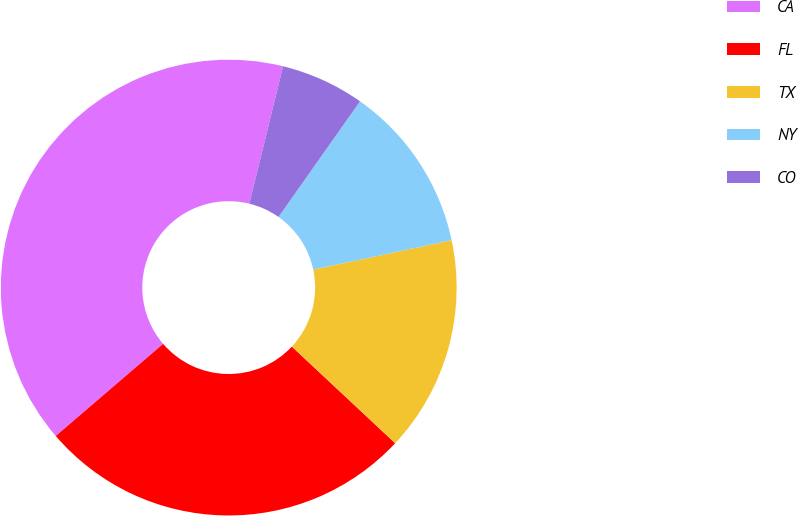Convert chart to OTSL. <chart><loc_0><loc_0><loc_500><loc_500><pie_chart><fcel>CA<fcel>FL<fcel>TX<fcel>NY<fcel>CO<nl><fcel>40.12%<fcel>26.75%<fcel>15.3%<fcel>11.89%<fcel>5.94%<nl></chart> 